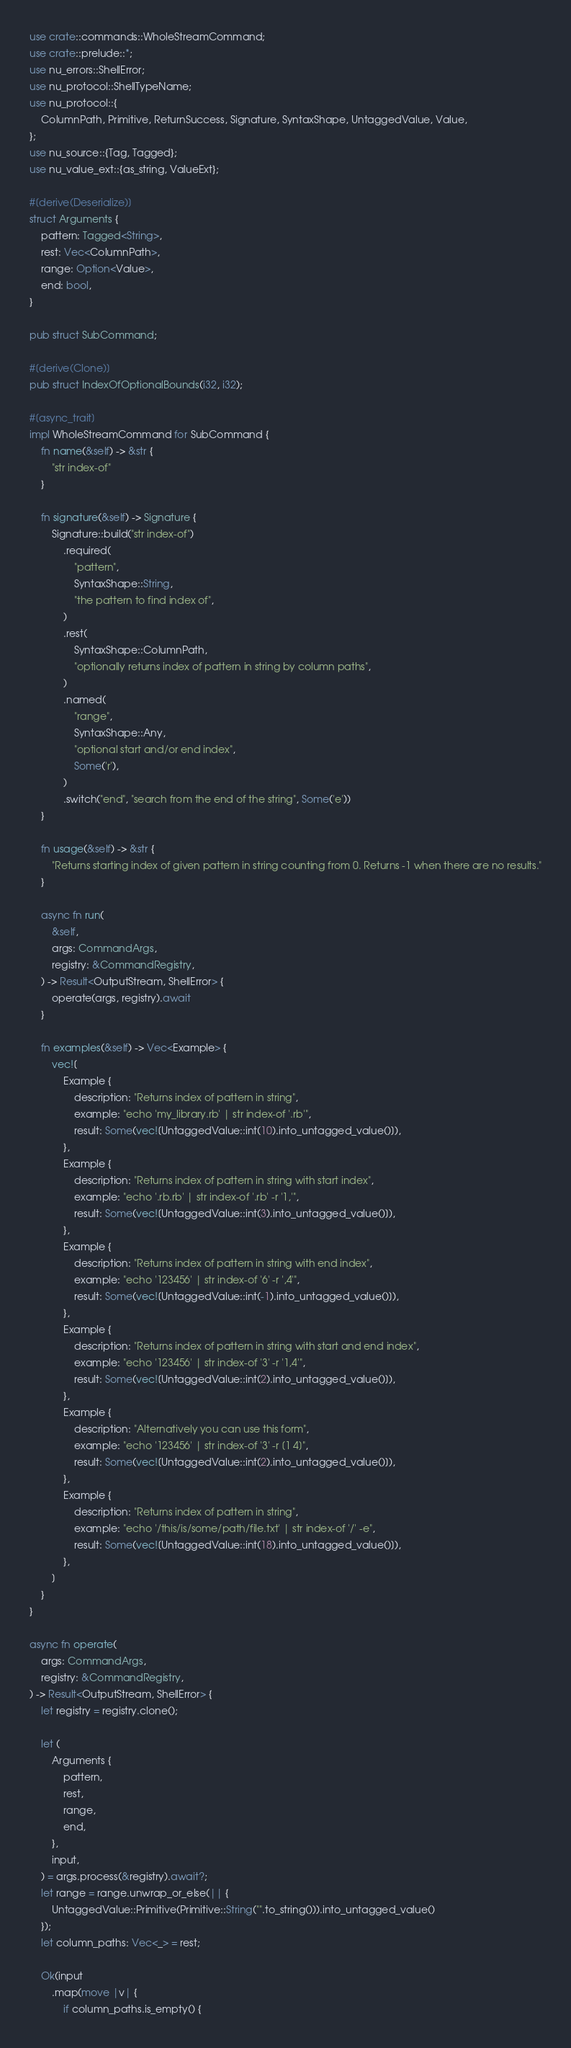<code> <loc_0><loc_0><loc_500><loc_500><_Rust_>use crate::commands::WholeStreamCommand;
use crate::prelude::*;
use nu_errors::ShellError;
use nu_protocol::ShellTypeName;
use nu_protocol::{
    ColumnPath, Primitive, ReturnSuccess, Signature, SyntaxShape, UntaggedValue, Value,
};
use nu_source::{Tag, Tagged};
use nu_value_ext::{as_string, ValueExt};

#[derive(Deserialize)]
struct Arguments {
    pattern: Tagged<String>,
    rest: Vec<ColumnPath>,
    range: Option<Value>,
    end: bool,
}

pub struct SubCommand;

#[derive(Clone)]
pub struct IndexOfOptionalBounds(i32, i32);

#[async_trait]
impl WholeStreamCommand for SubCommand {
    fn name(&self) -> &str {
        "str index-of"
    }

    fn signature(&self) -> Signature {
        Signature::build("str index-of")
            .required(
                "pattern",
                SyntaxShape::String,
                "the pattern to find index of",
            )
            .rest(
                SyntaxShape::ColumnPath,
                "optionally returns index of pattern in string by column paths",
            )
            .named(
                "range",
                SyntaxShape::Any,
                "optional start and/or end index",
                Some('r'),
            )
            .switch("end", "search from the end of the string", Some('e'))
    }

    fn usage(&self) -> &str {
        "Returns starting index of given pattern in string counting from 0. Returns -1 when there are no results."
    }

    async fn run(
        &self,
        args: CommandArgs,
        registry: &CommandRegistry,
    ) -> Result<OutputStream, ShellError> {
        operate(args, registry).await
    }

    fn examples(&self) -> Vec<Example> {
        vec![
            Example {
                description: "Returns index of pattern in string",
                example: "echo 'my_library.rb' | str index-of '.rb'",
                result: Some(vec![UntaggedValue::int(10).into_untagged_value()]),
            },
            Example {
                description: "Returns index of pattern in string with start index",
                example: "echo '.rb.rb' | str index-of '.rb' -r '1,'",
                result: Some(vec![UntaggedValue::int(3).into_untagged_value()]),
            },
            Example {
                description: "Returns index of pattern in string with end index",
                example: "echo '123456' | str index-of '6' -r ',4'",
                result: Some(vec![UntaggedValue::int(-1).into_untagged_value()]),
            },
            Example {
                description: "Returns index of pattern in string with start and end index",
                example: "echo '123456' | str index-of '3' -r '1,4'",
                result: Some(vec![UntaggedValue::int(2).into_untagged_value()]),
            },
            Example {
                description: "Alternatively you can use this form",
                example: "echo '123456' | str index-of '3' -r [1 4]",
                result: Some(vec![UntaggedValue::int(2).into_untagged_value()]),
            },
            Example {
                description: "Returns index of pattern in string",
                example: "echo '/this/is/some/path/file.txt' | str index-of '/' -e",
                result: Some(vec![UntaggedValue::int(18).into_untagged_value()]),
            },
        ]
    }
}

async fn operate(
    args: CommandArgs,
    registry: &CommandRegistry,
) -> Result<OutputStream, ShellError> {
    let registry = registry.clone();

    let (
        Arguments {
            pattern,
            rest,
            range,
            end,
        },
        input,
    ) = args.process(&registry).await?;
    let range = range.unwrap_or_else(|| {
        UntaggedValue::Primitive(Primitive::String("".to_string())).into_untagged_value()
    });
    let column_paths: Vec<_> = rest;

    Ok(input
        .map(move |v| {
            if column_paths.is_empty() {</code> 